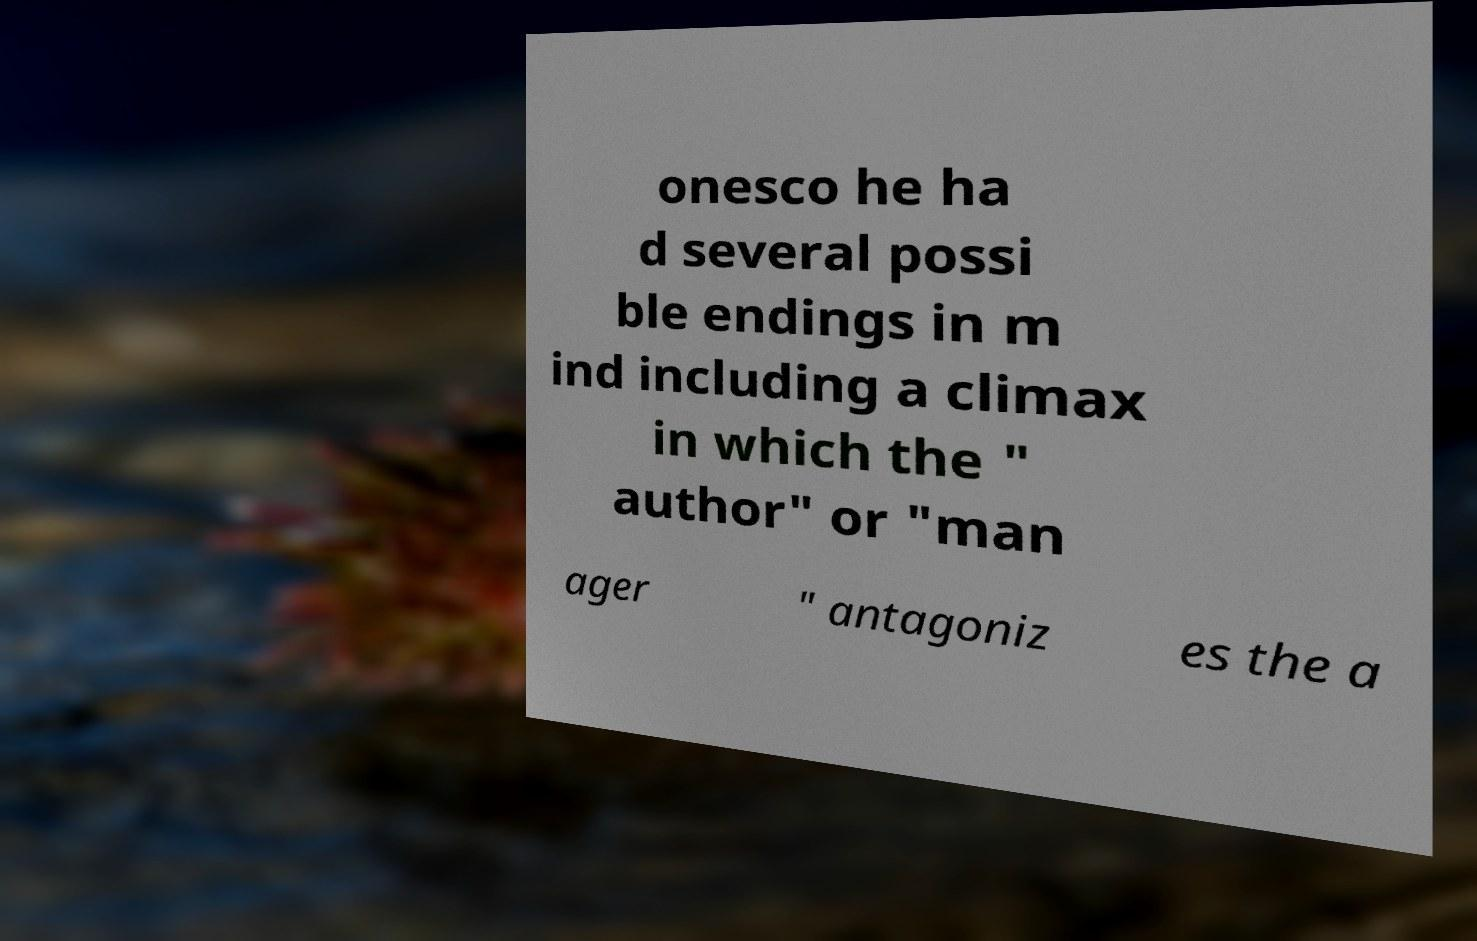Please read and relay the text visible in this image. What does it say? onesco he ha d several possi ble endings in m ind including a climax in which the " author" or "man ager " antagoniz es the a 